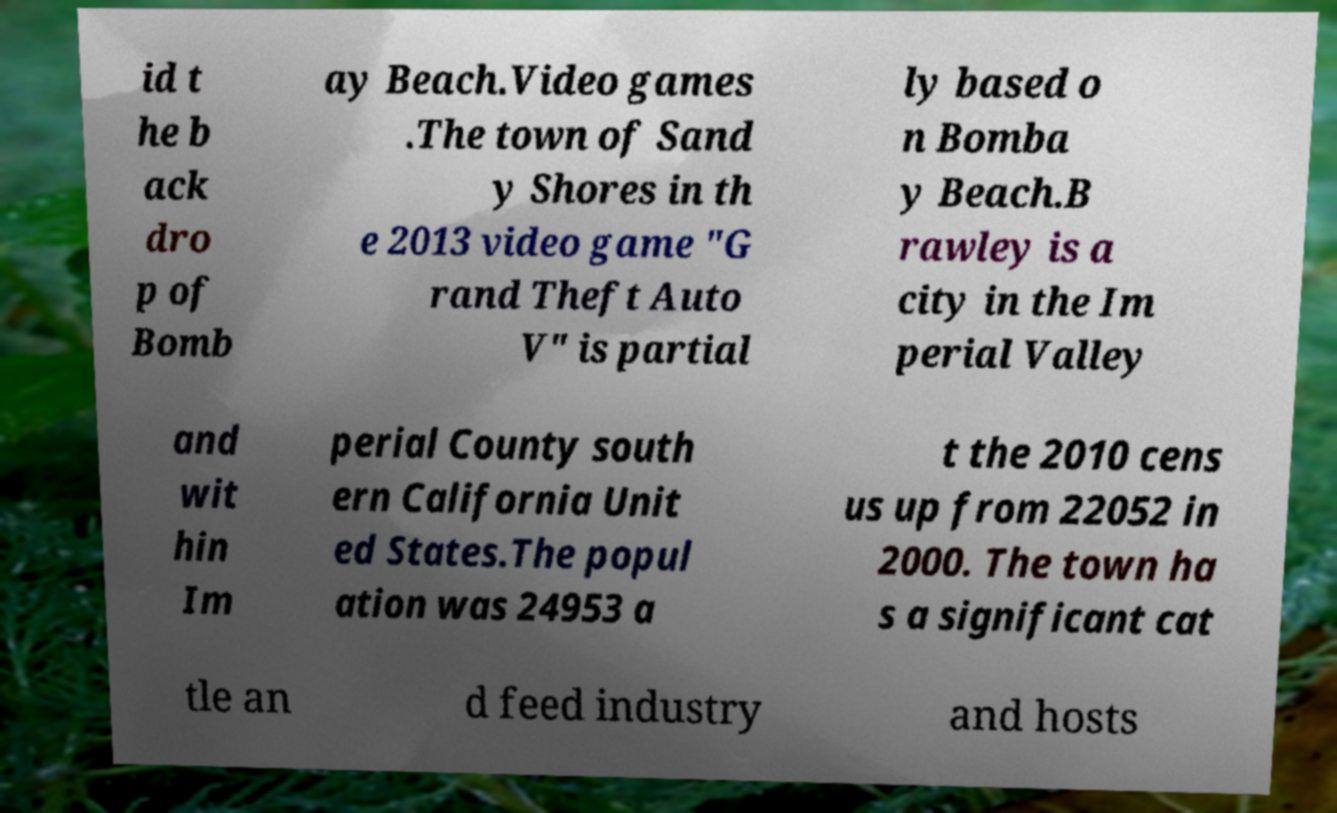For documentation purposes, I need the text within this image transcribed. Could you provide that? id t he b ack dro p of Bomb ay Beach.Video games .The town of Sand y Shores in th e 2013 video game "G rand Theft Auto V" is partial ly based o n Bomba y Beach.B rawley is a city in the Im perial Valley and wit hin Im perial County south ern California Unit ed States.The popul ation was 24953 a t the 2010 cens us up from 22052 in 2000. The town ha s a significant cat tle an d feed industry and hosts 